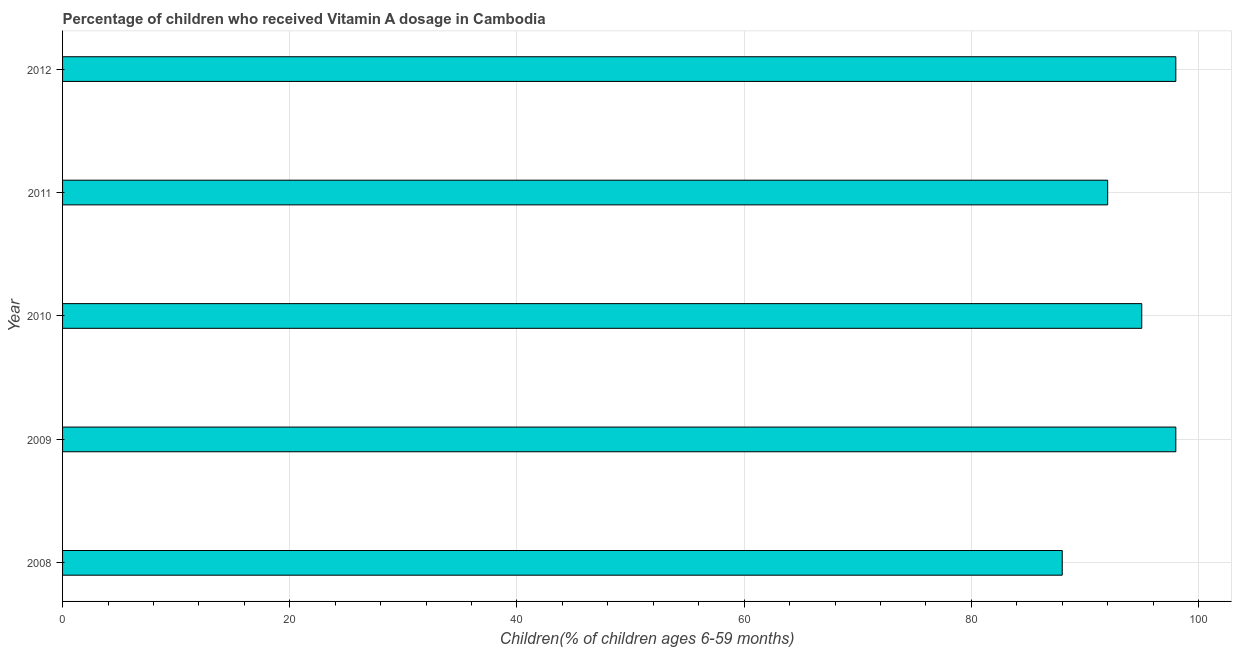What is the title of the graph?
Provide a short and direct response. Percentage of children who received Vitamin A dosage in Cambodia. What is the label or title of the X-axis?
Ensure brevity in your answer.  Children(% of children ages 6-59 months). What is the vitamin a supplementation coverage rate in 2009?
Provide a succinct answer. 98. Across all years, what is the maximum vitamin a supplementation coverage rate?
Give a very brief answer. 98. Across all years, what is the minimum vitamin a supplementation coverage rate?
Offer a terse response. 88. In which year was the vitamin a supplementation coverage rate maximum?
Give a very brief answer. 2009. What is the sum of the vitamin a supplementation coverage rate?
Provide a short and direct response. 471. What is the average vitamin a supplementation coverage rate per year?
Ensure brevity in your answer.  94. What is the median vitamin a supplementation coverage rate?
Make the answer very short. 95. In how many years, is the vitamin a supplementation coverage rate greater than 4 %?
Provide a short and direct response. 5. What is the ratio of the vitamin a supplementation coverage rate in 2009 to that in 2010?
Offer a very short reply. 1.03. Is the sum of the vitamin a supplementation coverage rate in 2011 and 2012 greater than the maximum vitamin a supplementation coverage rate across all years?
Your response must be concise. Yes. How many bars are there?
Your answer should be compact. 5. Are all the bars in the graph horizontal?
Provide a succinct answer. Yes. What is the difference between two consecutive major ticks on the X-axis?
Keep it short and to the point. 20. Are the values on the major ticks of X-axis written in scientific E-notation?
Provide a succinct answer. No. What is the Children(% of children ages 6-59 months) of 2009?
Provide a succinct answer. 98. What is the Children(% of children ages 6-59 months) of 2010?
Your answer should be very brief. 95. What is the Children(% of children ages 6-59 months) in 2011?
Offer a very short reply. 92. What is the Children(% of children ages 6-59 months) in 2012?
Provide a succinct answer. 98. What is the difference between the Children(% of children ages 6-59 months) in 2008 and 2009?
Offer a terse response. -10. What is the difference between the Children(% of children ages 6-59 months) in 2009 and 2012?
Make the answer very short. 0. What is the difference between the Children(% of children ages 6-59 months) in 2010 and 2012?
Ensure brevity in your answer.  -3. What is the ratio of the Children(% of children ages 6-59 months) in 2008 to that in 2009?
Provide a succinct answer. 0.9. What is the ratio of the Children(% of children ages 6-59 months) in 2008 to that in 2010?
Offer a very short reply. 0.93. What is the ratio of the Children(% of children ages 6-59 months) in 2008 to that in 2011?
Provide a short and direct response. 0.96. What is the ratio of the Children(% of children ages 6-59 months) in 2008 to that in 2012?
Give a very brief answer. 0.9. What is the ratio of the Children(% of children ages 6-59 months) in 2009 to that in 2010?
Offer a terse response. 1.03. What is the ratio of the Children(% of children ages 6-59 months) in 2009 to that in 2011?
Offer a terse response. 1.06. What is the ratio of the Children(% of children ages 6-59 months) in 2009 to that in 2012?
Your answer should be very brief. 1. What is the ratio of the Children(% of children ages 6-59 months) in 2010 to that in 2011?
Your answer should be compact. 1.03. What is the ratio of the Children(% of children ages 6-59 months) in 2011 to that in 2012?
Provide a succinct answer. 0.94. 